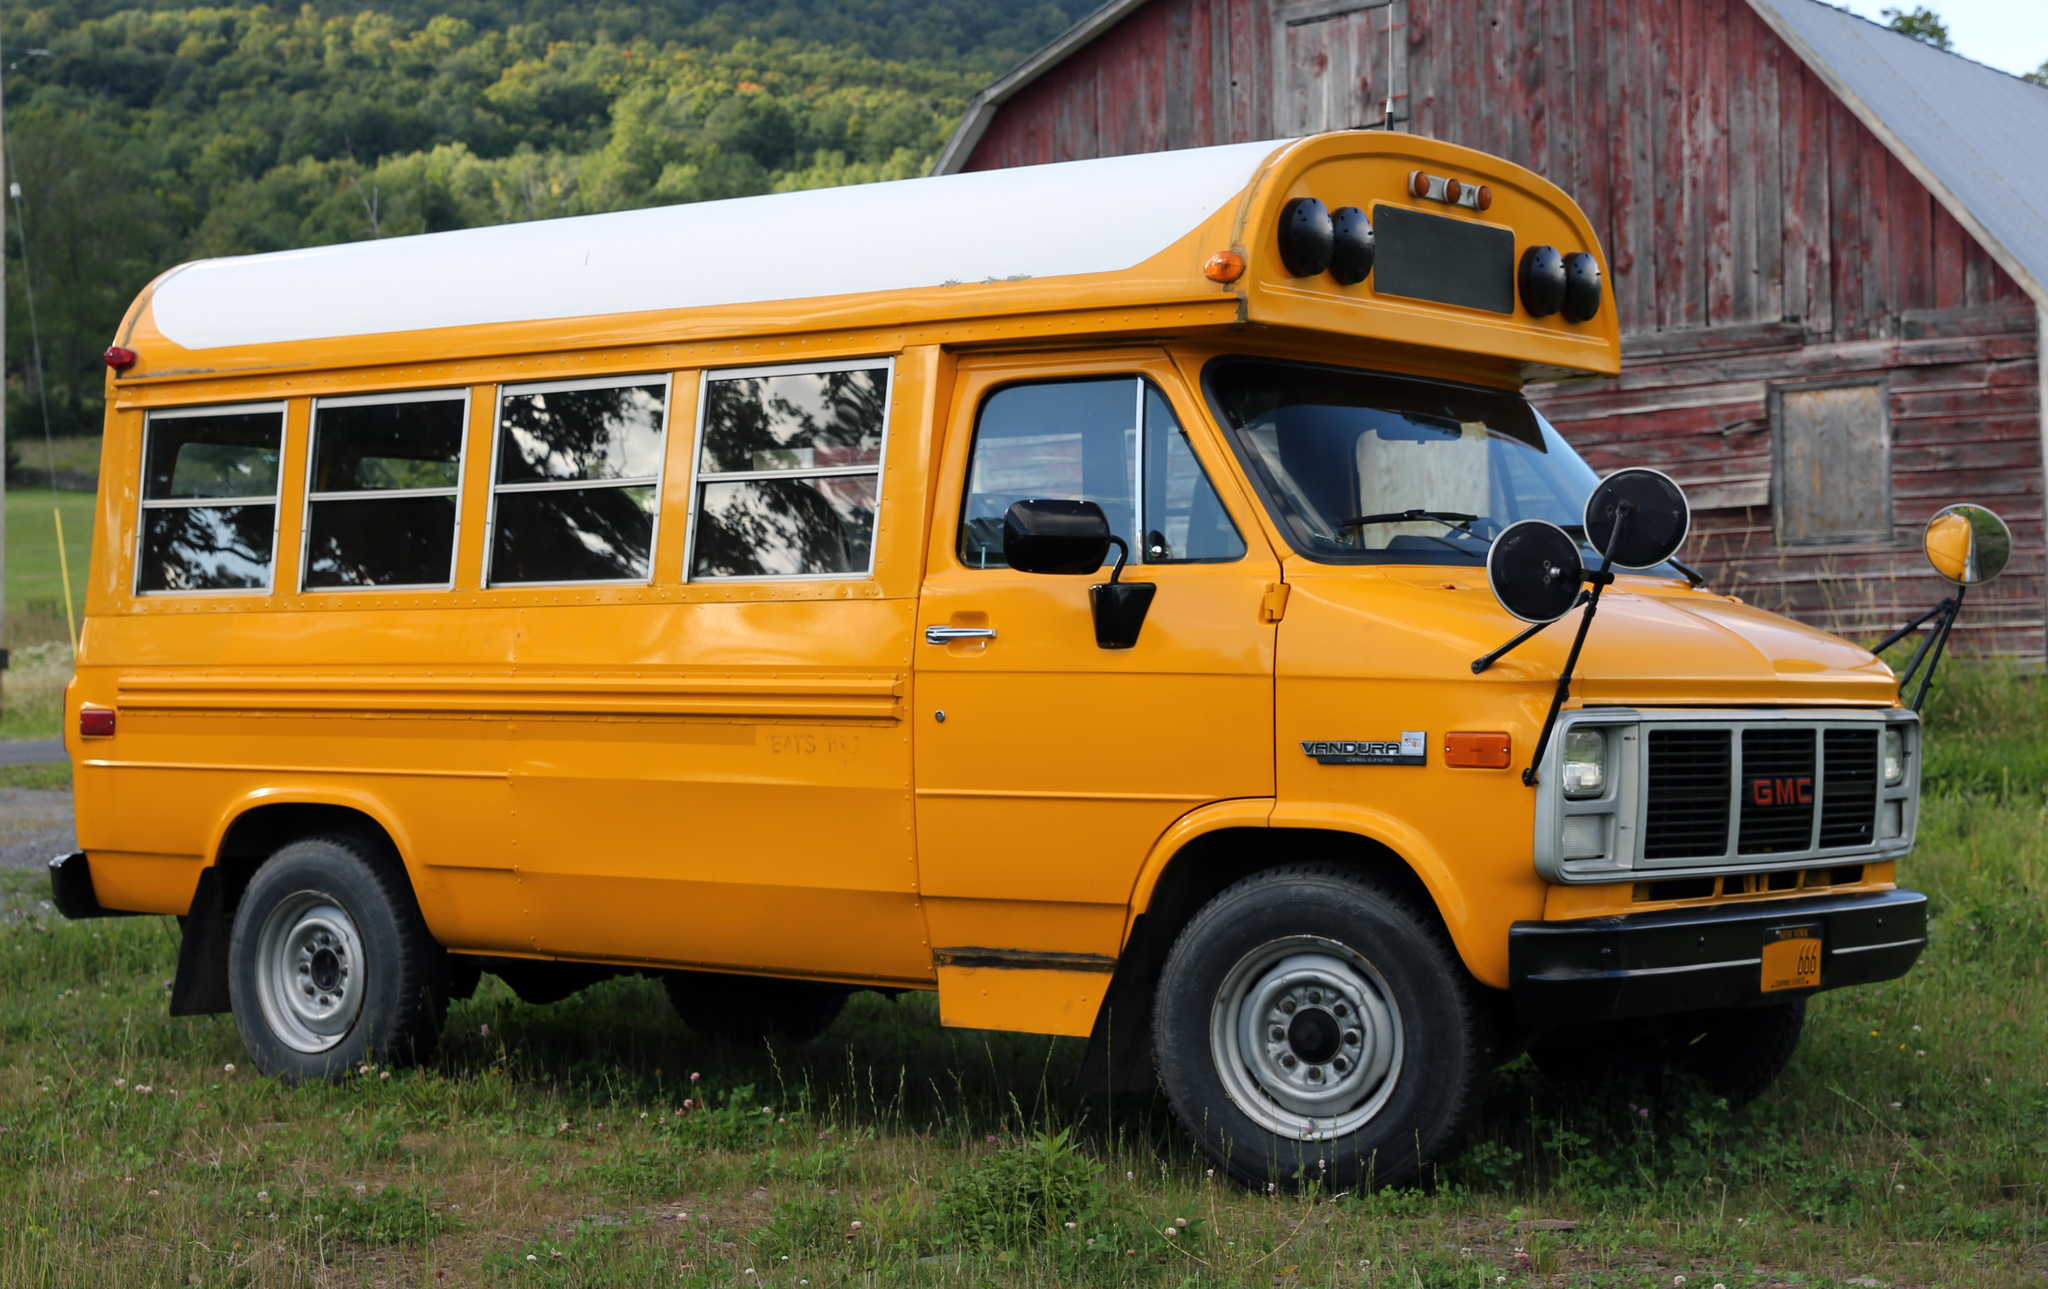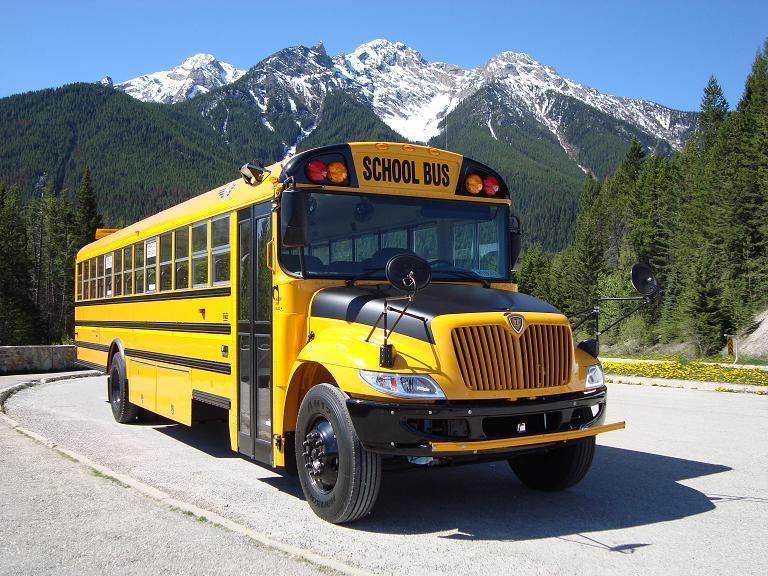The first image is the image on the left, the second image is the image on the right. Analyze the images presented: Is the assertion "A bus is in the sun." valid? Answer yes or no. Yes. The first image is the image on the left, the second image is the image on the right. Given the left and right images, does the statement "The buses in the left and right images are displayed horizontally and back-to-back." hold true? Answer yes or no. No. 